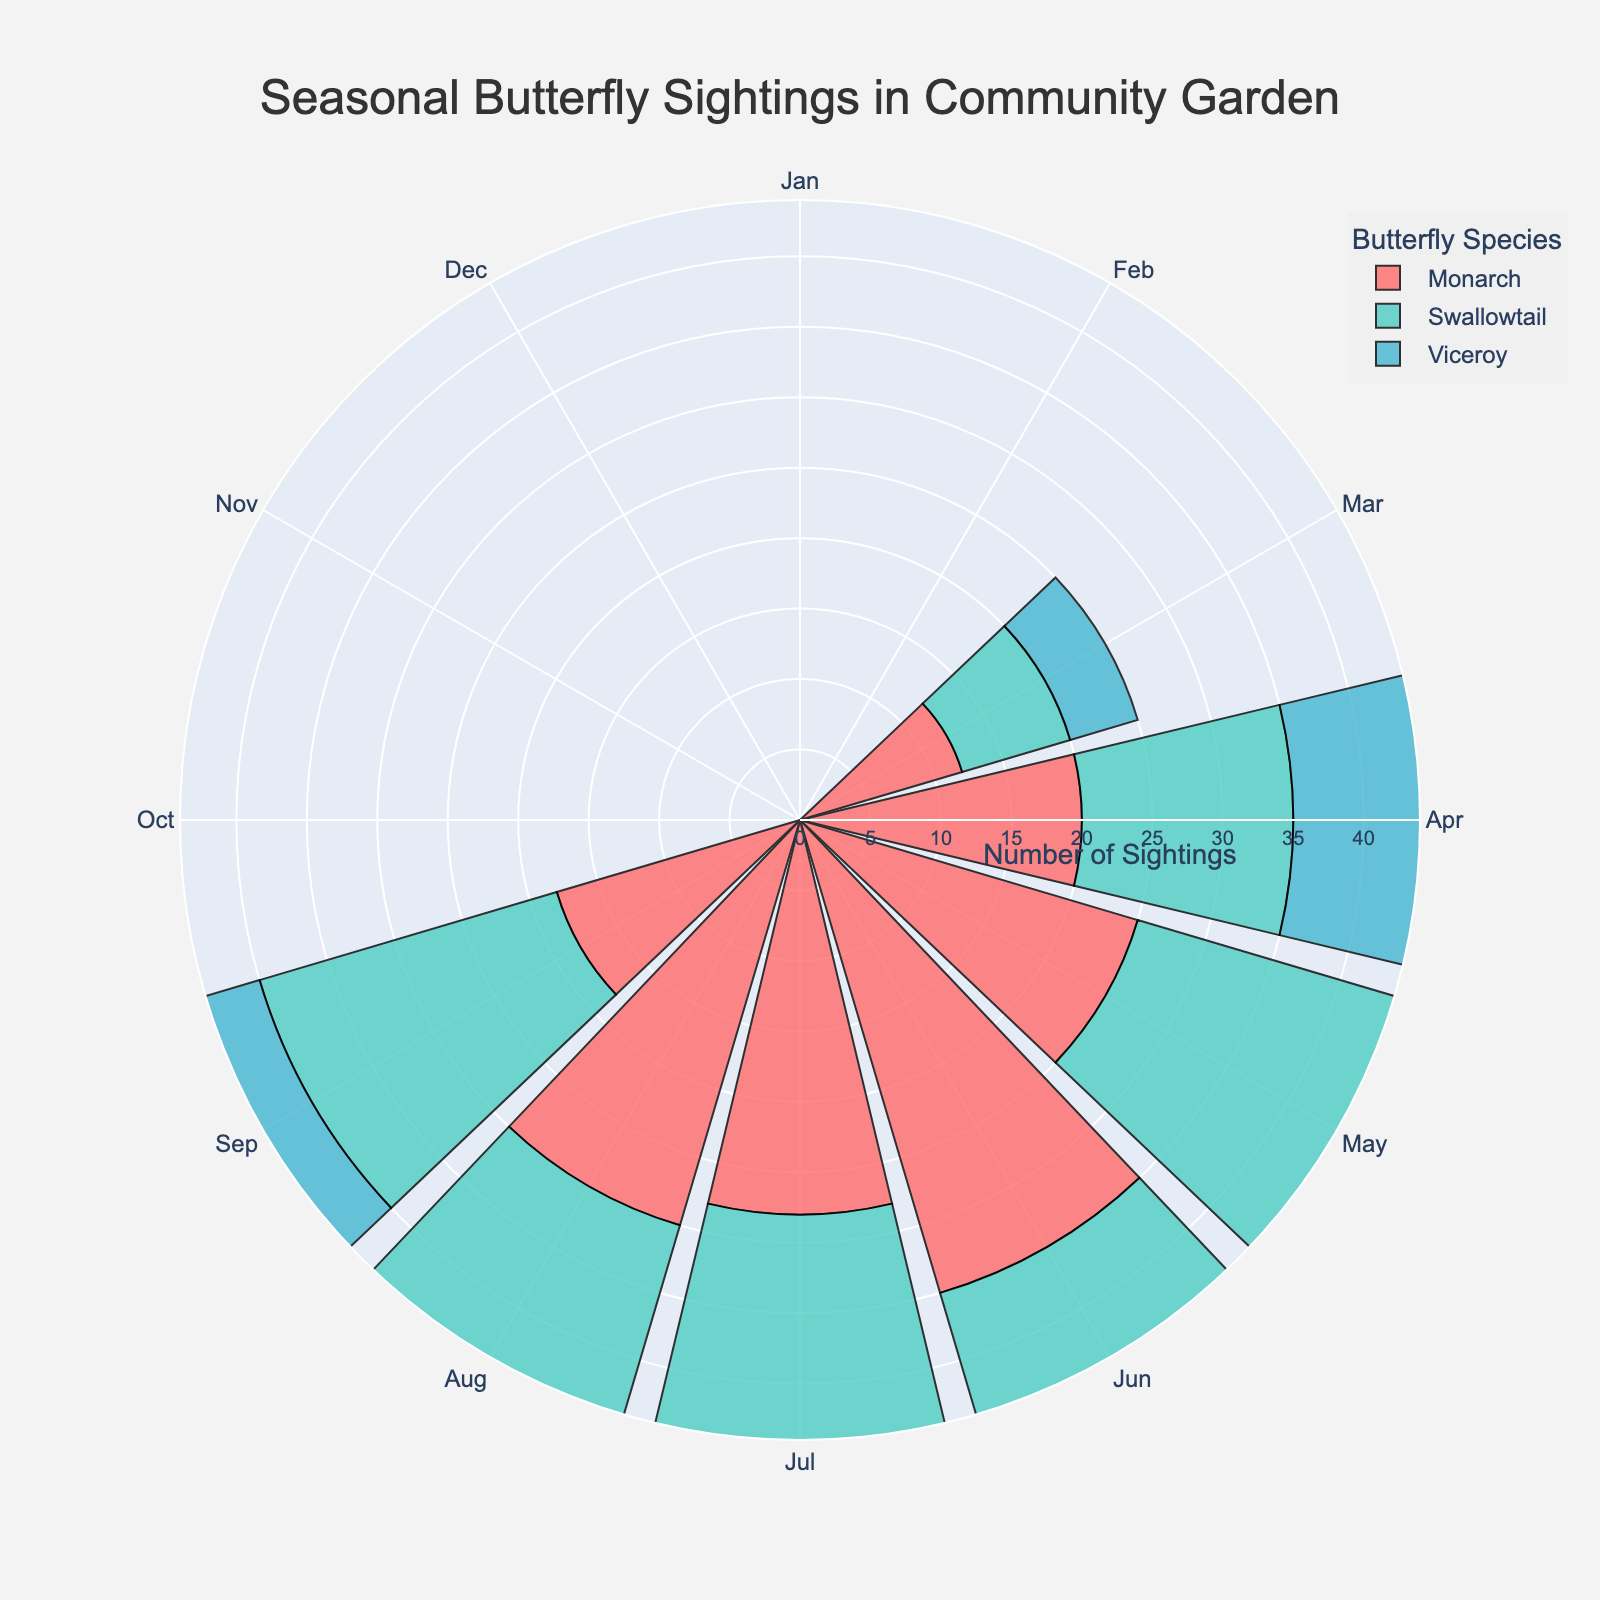What is the title of the chart? The title is typically found at the top of the chart. Here it says "Seasonal Butterfly Sightings in Community Garden."
Answer: Seasonal Butterfly Sightings in Community Garden Which species had the most sightings in July? The bar for Swallowtail in July is the longest compared to the other species.
Answer: Swallowtail What is the difference in Monarch sightings between May and August? Longitude lines (July and August) for Monarch: May = 25, August = 30. Difference = 30 - 25 = 5.
Answer: 5 Which month had the lowest total butterfly sightings? Sum the sightings for each species for every month and compare: March (12+8+5=25), April (20+15+10=45), May (25+30+18=73), June (35+40+22=97), July (28+36+25=89), August (30+38+27=95), September (18+22+19=59). March total = 25 is the lowest.
Answer: March How does the total sighting of Swallowtail in June compare to Monarch in June? Check the bar heights for June: Swallowtail = 40, Monarch = 35. Swallowtail June > Monarch June.
Answer: Swallowtail is greater What is the combined total of sightings for Viceroy in March, April, and May? Viceroy sightings for the months are March = 5, April = 10, May = 18. Sum = 5 + 10 + 18 = 33.
Answer: 33 What month has the highest number of Monarch sightings? Comparing the heights of the bars for each month, June has the highest bar for Monarch with 35 sightings.
Answer: June Are there any months where Viceroy sightings are higher than Monarch sightings? Compare the bar heights for each month: In July (25 for Viceroy, 28 for Monarch) they are close but Monarch is always higher in all months.
Answer: No What's the average sighting of Swallowtail across all months? Sum all Swallowtail sightings and divide by the number of months: (8+15+30+40+36+38+22) = 189; 189 / 7 = 27
Answer: 27 